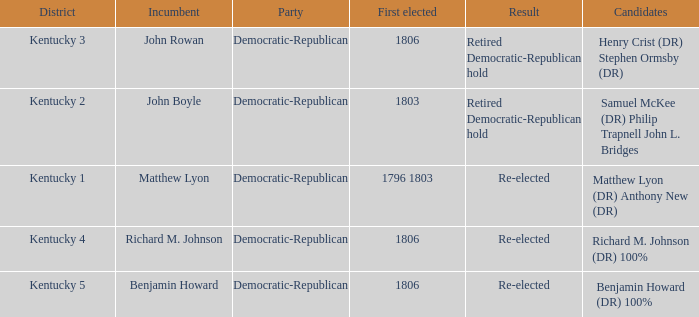Name the candidates for john boyle Samuel McKee (DR) Philip Trapnell John L. Bridges. 